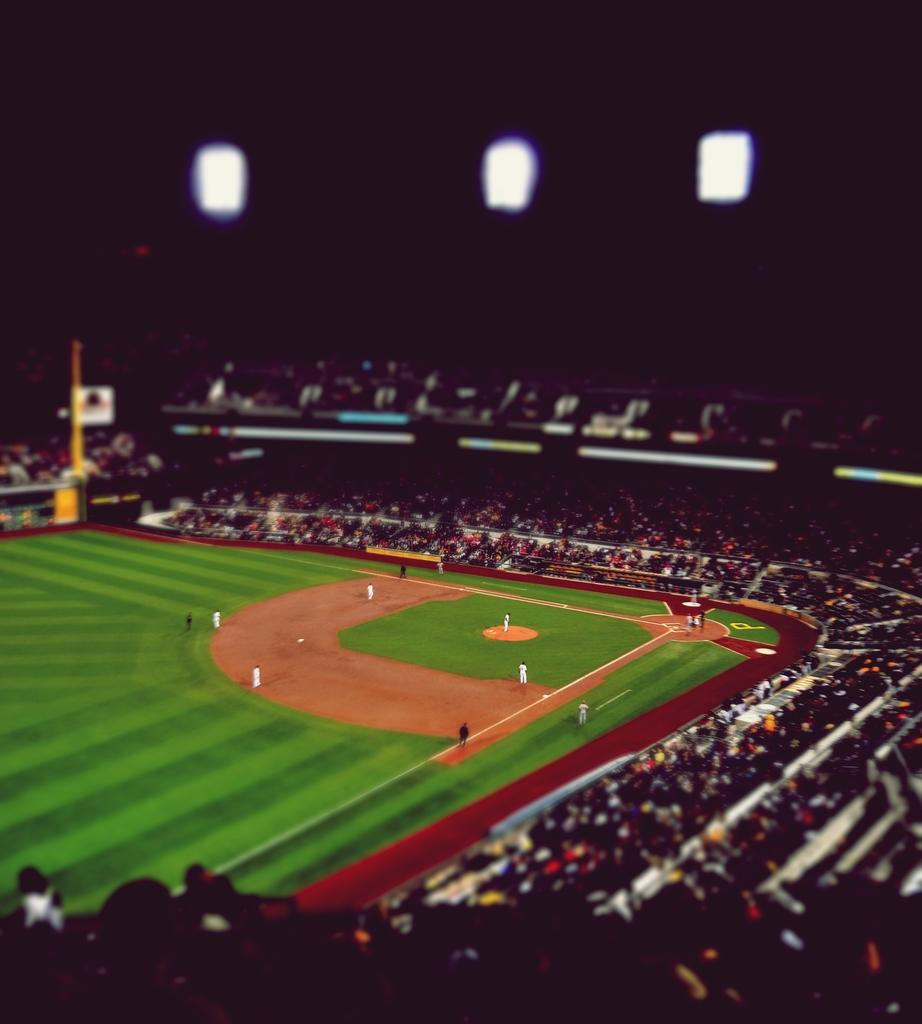What type of location is shown in the image? The image depicts a baseball ground. Can you describe the people present in the image? There are people standing in the ground, and there are groups of people sitting and standing. What object can be seen in the image besides people? There appears to be a pole in the image in the image. What type of pets can be seen playing with mice in the image? There are no pets or mice present in the image; it depicts a baseball ground with people. Is there any blood visible on the ground in the image? There is no blood visible in the image; it shows a baseball ground with people and a pole. 